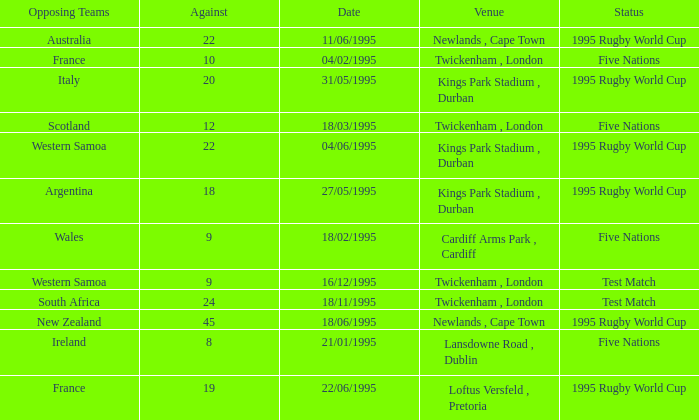When was the status test match with an opposing team of south africa? 18/11/1995. 